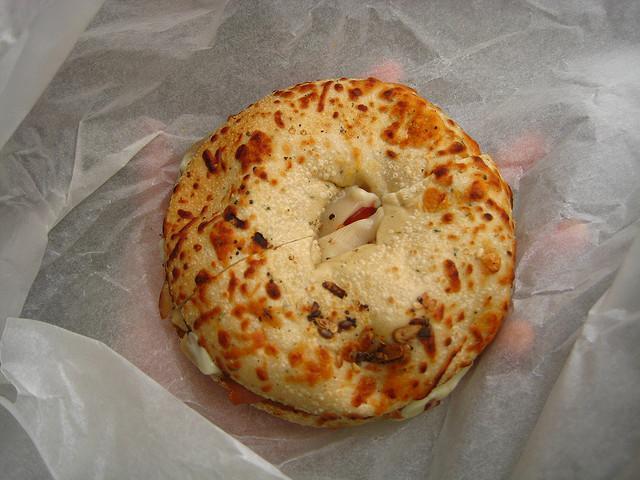Is the given caption "The sandwich is touching the person." fitting for the image?
Answer yes or no. No. Does the description: "The person is touching the sandwich." accurately reflect the image?
Answer yes or no. No. 